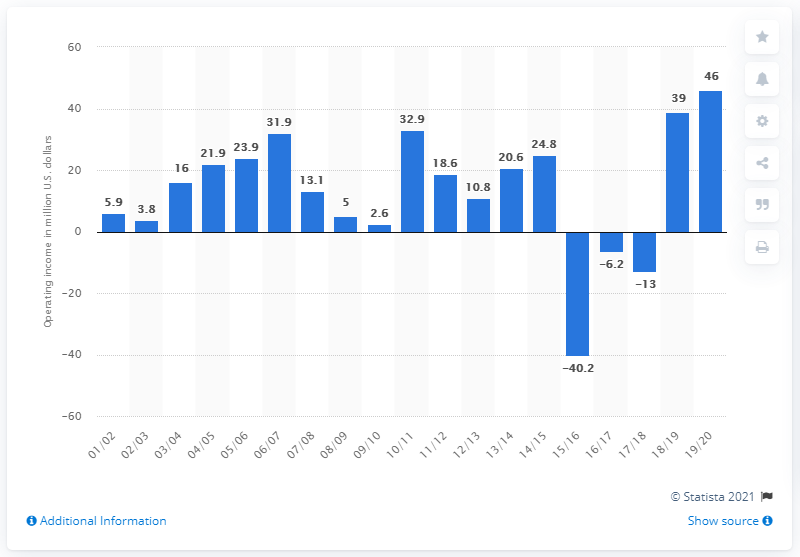Point out several critical features in this image. The operating income of the Cleveland Cavaliers in the 2019/2020 season was 46 million dollars. 